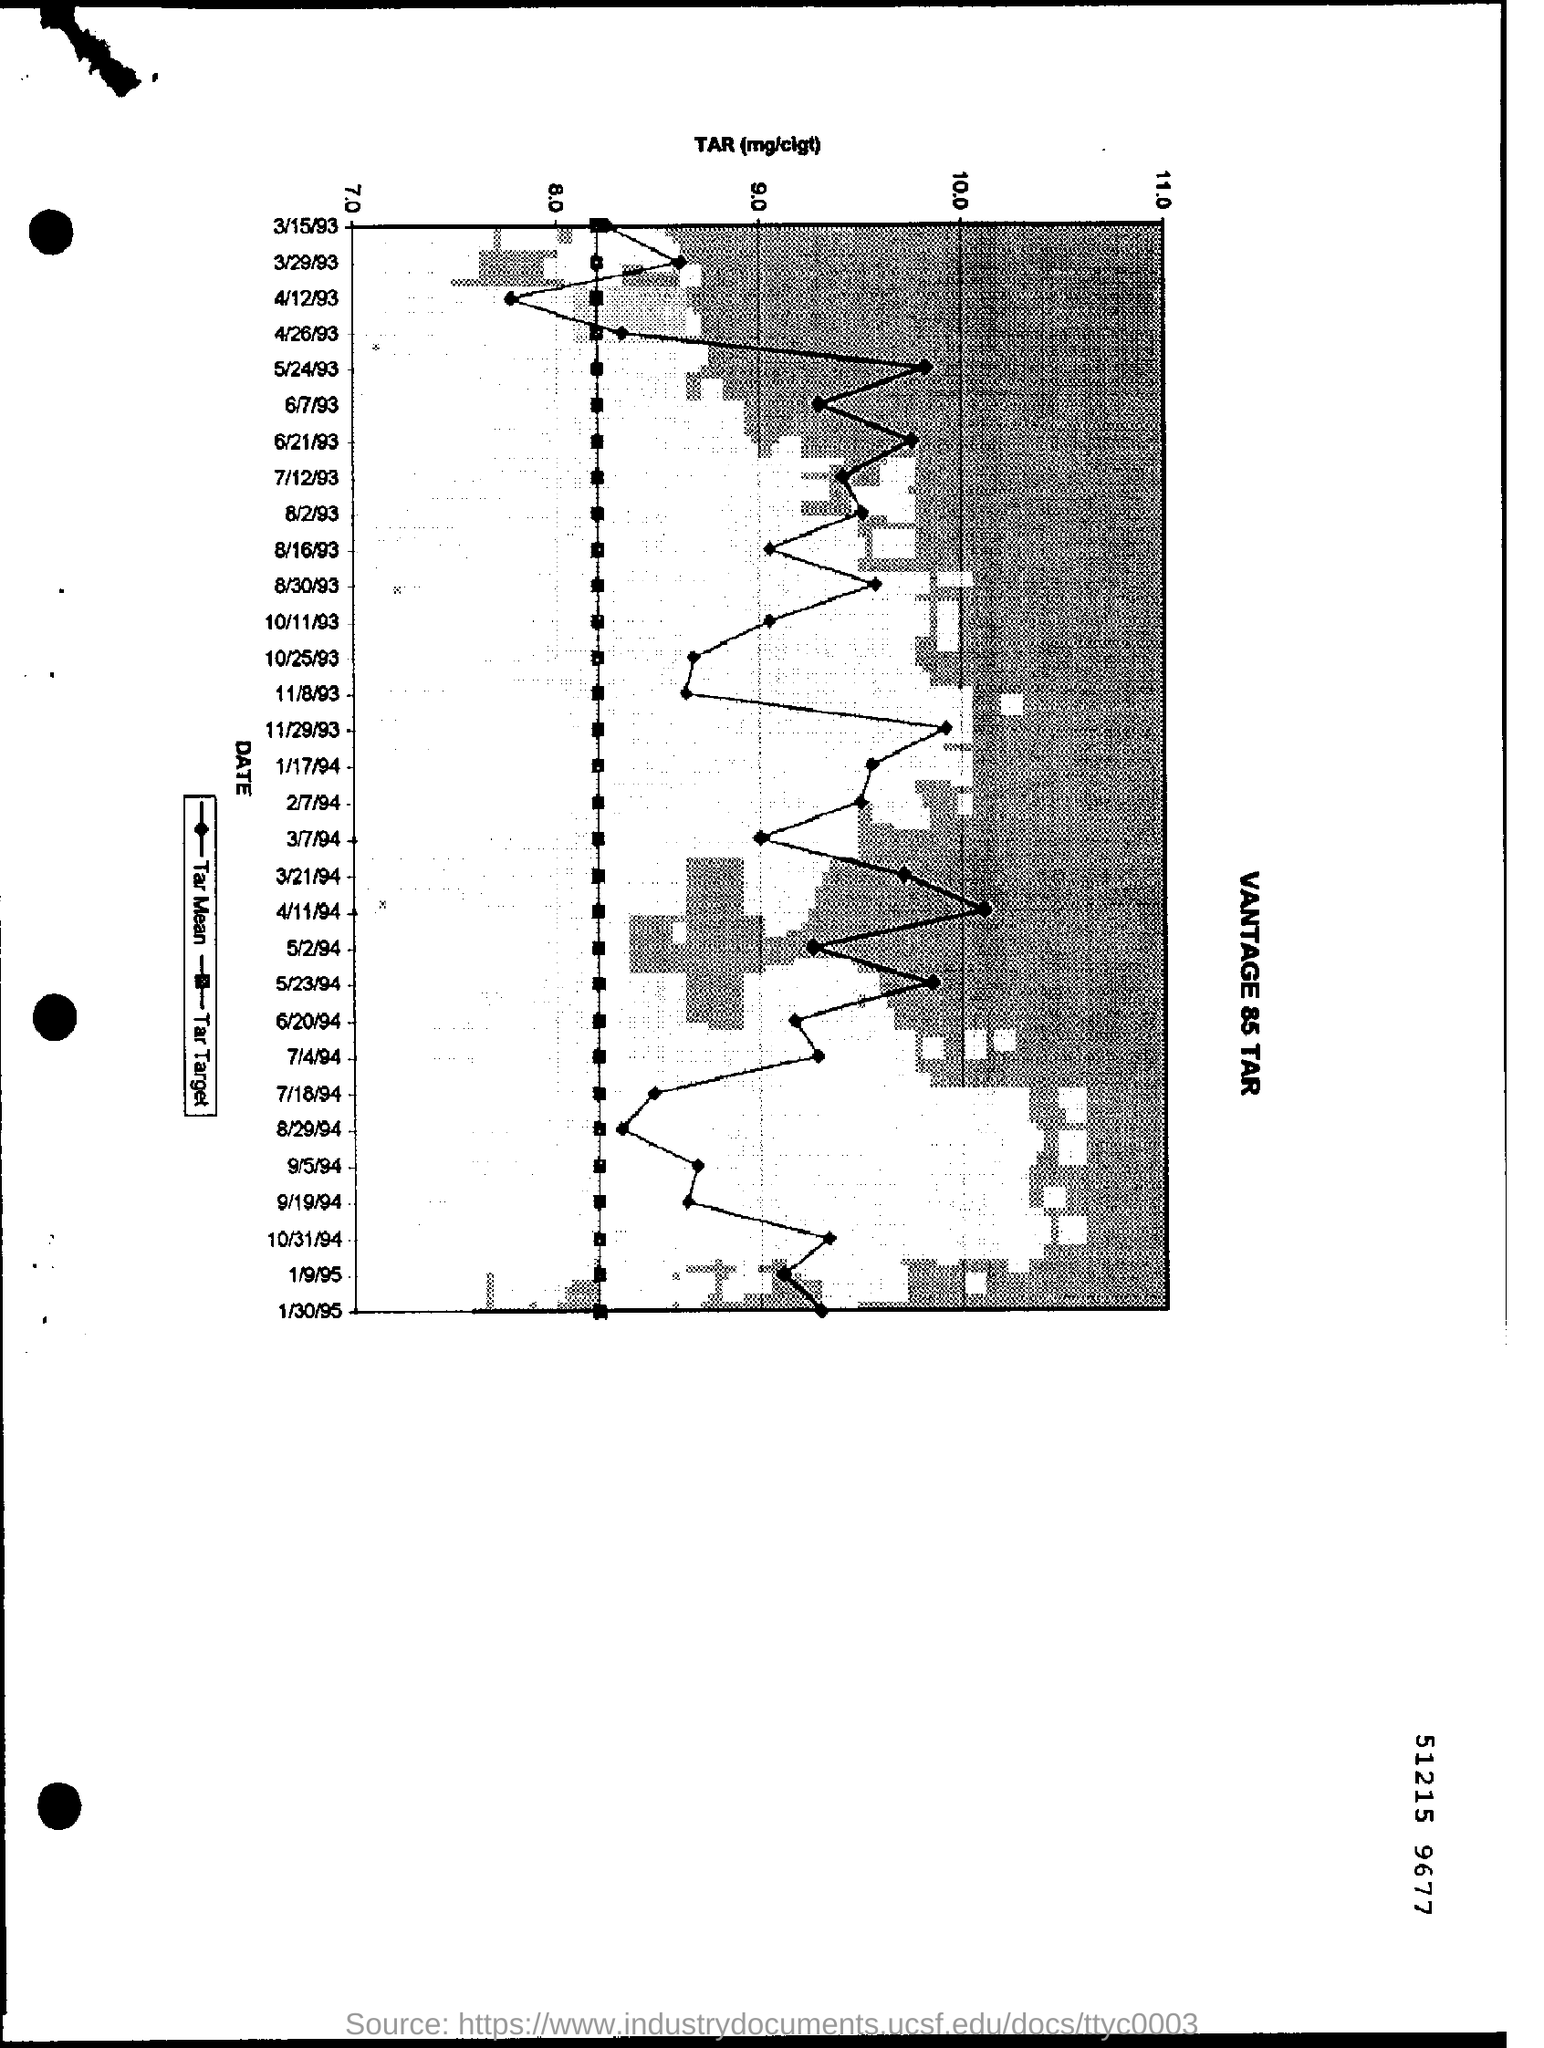In which date is the higher TAR rate shown in the graph?
Your response must be concise. 4/11/94. How much is the starting rate of the TAR Bar?
Make the answer very short. 7. 